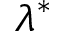<formula> <loc_0><loc_0><loc_500><loc_500>\lambda ^ { * }</formula> 